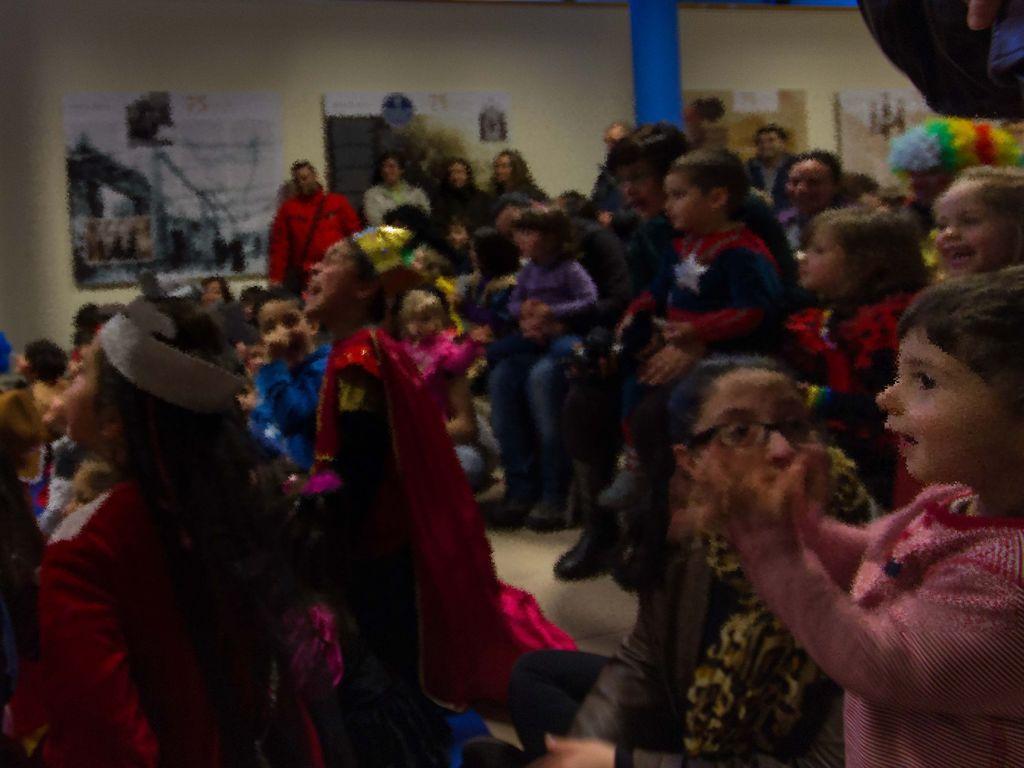Can you describe this image briefly? In this image, we can see some people sitting and there are some people standing and there is a wall, there are some posters on the wall. 